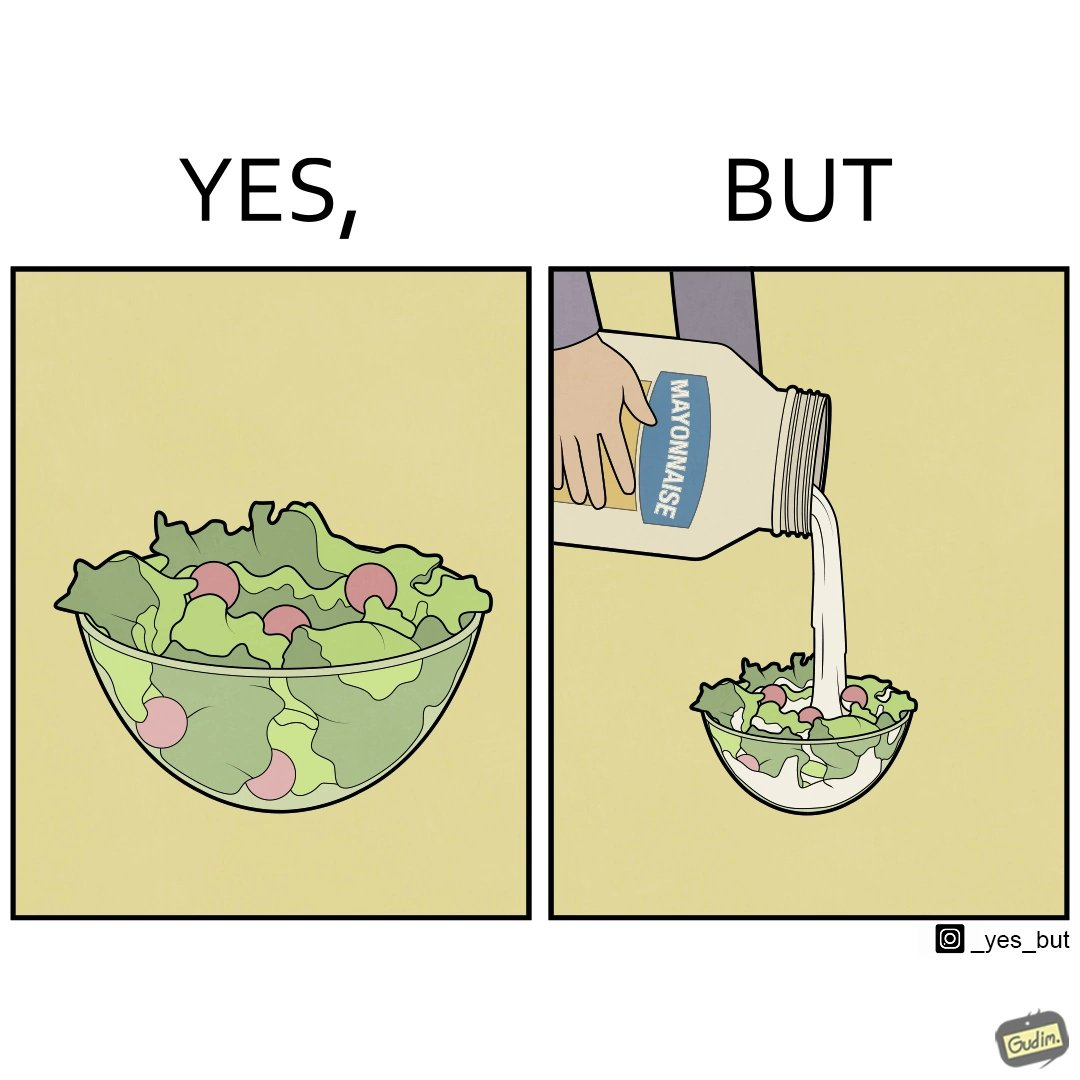Describe what you see in the left and right parts of this image. In the left part of the image: salad in a bowl In the right part of the image: pouring mayonnaise sauce on salad in a bowl 